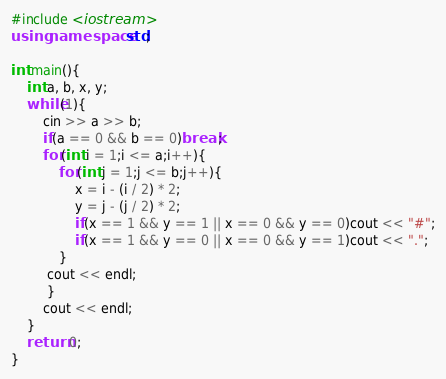<code> <loc_0><loc_0><loc_500><loc_500><_C++_>#include <iostream>
using namespace std;

int main(){
    int a, b, x, y;
    while(1){
        cin >> a >> b;
        if(a == 0 && b == 0)break;
        for(int i = 1;i <= a;i++){
            for(int j = 1;j <= b;j++){
                x = i - (i / 2) * 2;
                y = j - (j / 2) * 2;
                if(x == 1 && y == 1 || x == 0 && y == 0)cout << "#";
                if(x == 1 && y == 0 || x == 0 && y == 1)cout << ".";
            }
         cout << endl;
         }
        cout << endl;
    }
    return 0;
}</code> 